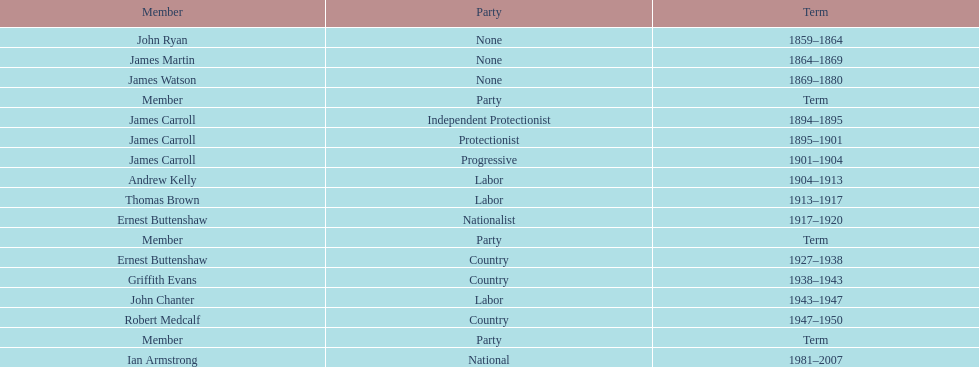How many years of service do the members of the second incarnation have combined? 26. Could you help me parse every detail presented in this table? {'header': ['Member', 'Party', 'Term'], 'rows': [['John Ryan', 'None', '1859–1864'], ['James Martin', 'None', '1864–1869'], ['James Watson', 'None', '1869–1880'], ['Member', 'Party', 'Term'], ['James Carroll', 'Independent Protectionist', '1894–1895'], ['James Carroll', 'Protectionist', '1895–1901'], ['James Carroll', 'Progressive', '1901–1904'], ['Andrew Kelly', 'Labor', '1904–1913'], ['Thomas Brown', 'Labor', '1913–1917'], ['Ernest Buttenshaw', 'Nationalist', '1917–1920'], ['Member', 'Party', 'Term'], ['Ernest Buttenshaw', 'Country', '1927–1938'], ['Griffith Evans', 'Country', '1938–1943'], ['John Chanter', 'Labor', '1943–1947'], ['Robert Medcalf', 'Country', '1947–1950'], ['Member', 'Party', 'Term'], ['Ian Armstrong', 'National', '1981–2007']]} 